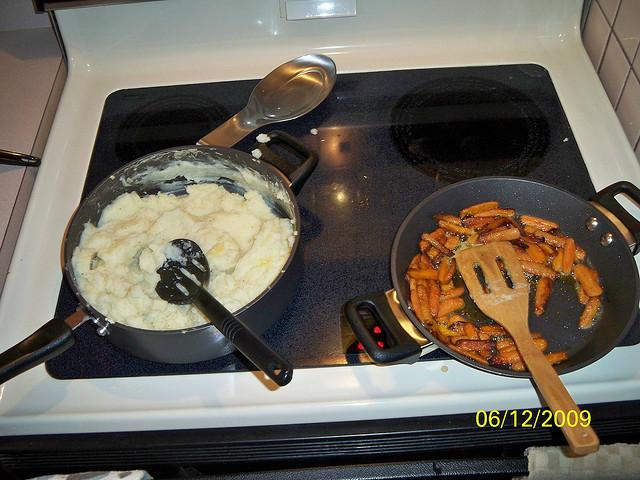What is the silver object above the mashed potatoes pan used for?

Choices:
A) spoon rest
B) medicine
C) stirring
D) serving spoon rest 